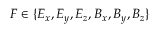Convert formula to latex. <formula><loc_0><loc_0><loc_500><loc_500>F \in \{ E _ { x } , E _ { y } , E _ { z } , B _ { x } , B _ { y } , B _ { z } \}</formula> 